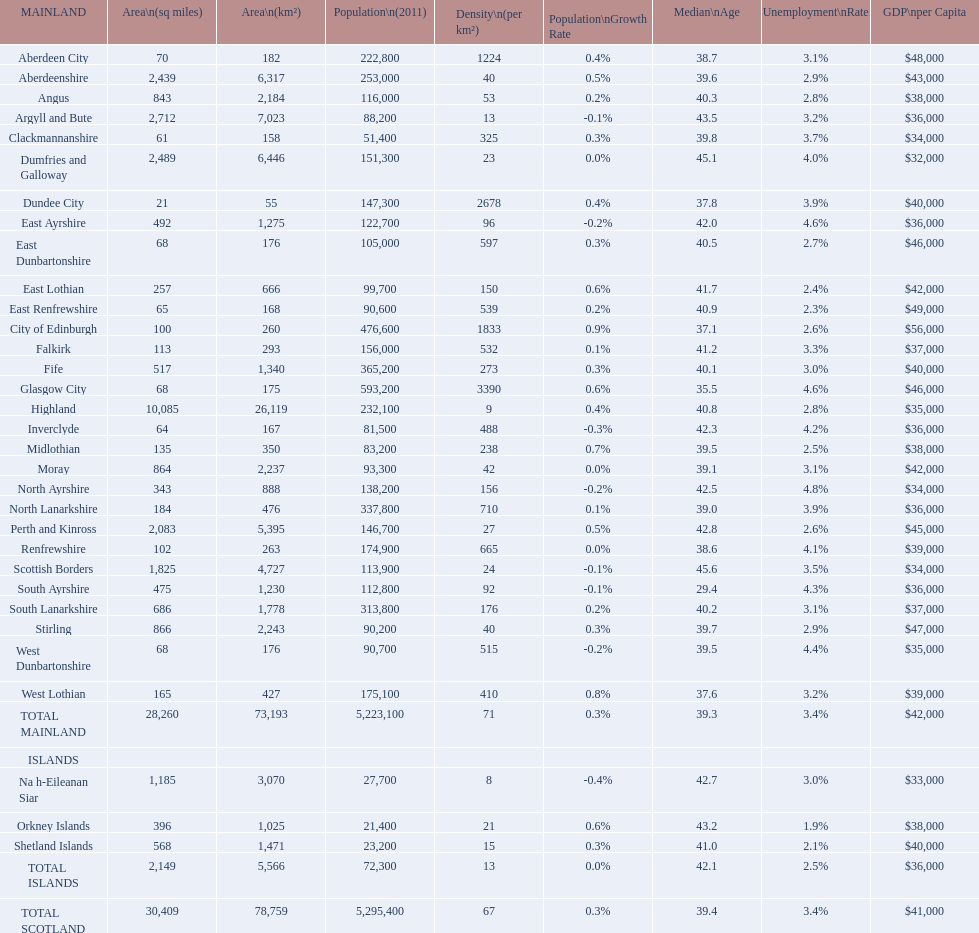What number of mainlands have populations under 100,000? 9. 